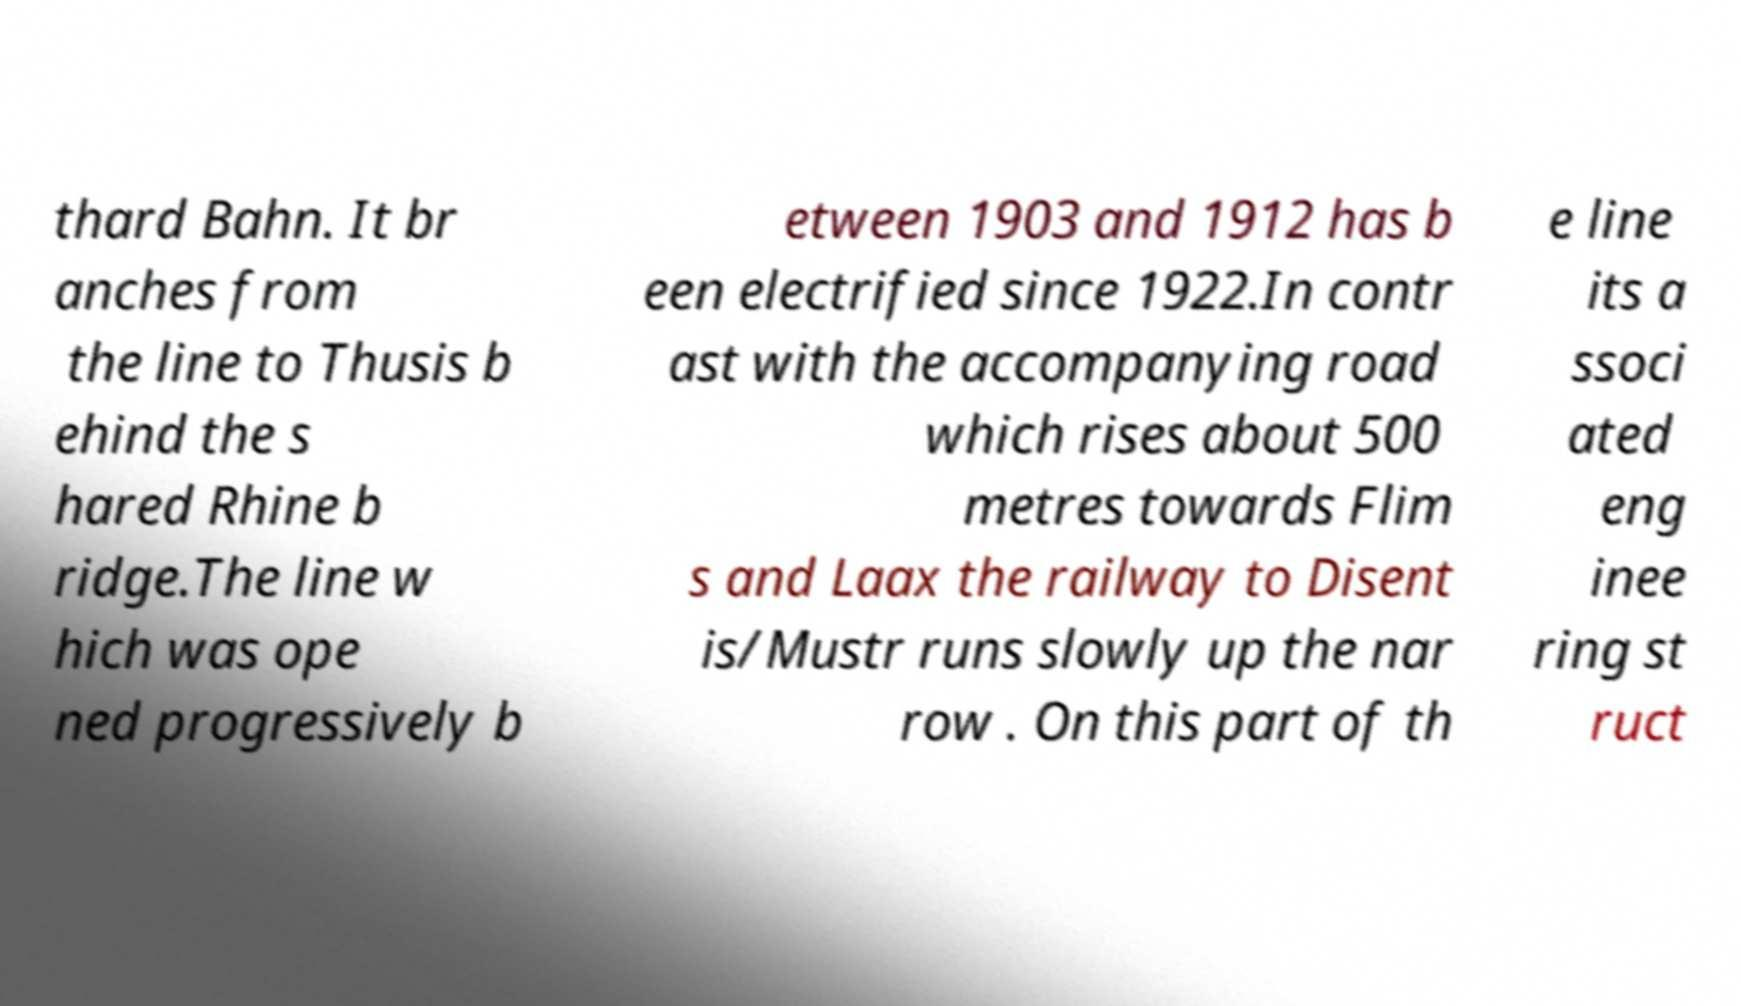Can you read and provide the text displayed in the image?This photo seems to have some interesting text. Can you extract and type it out for me? thard Bahn. It br anches from the line to Thusis b ehind the s hared Rhine b ridge.The line w hich was ope ned progressively b etween 1903 and 1912 has b een electrified since 1922.In contr ast with the accompanying road which rises about 500 metres towards Flim s and Laax the railway to Disent is/Mustr runs slowly up the nar row . On this part of th e line its a ssoci ated eng inee ring st ruct 